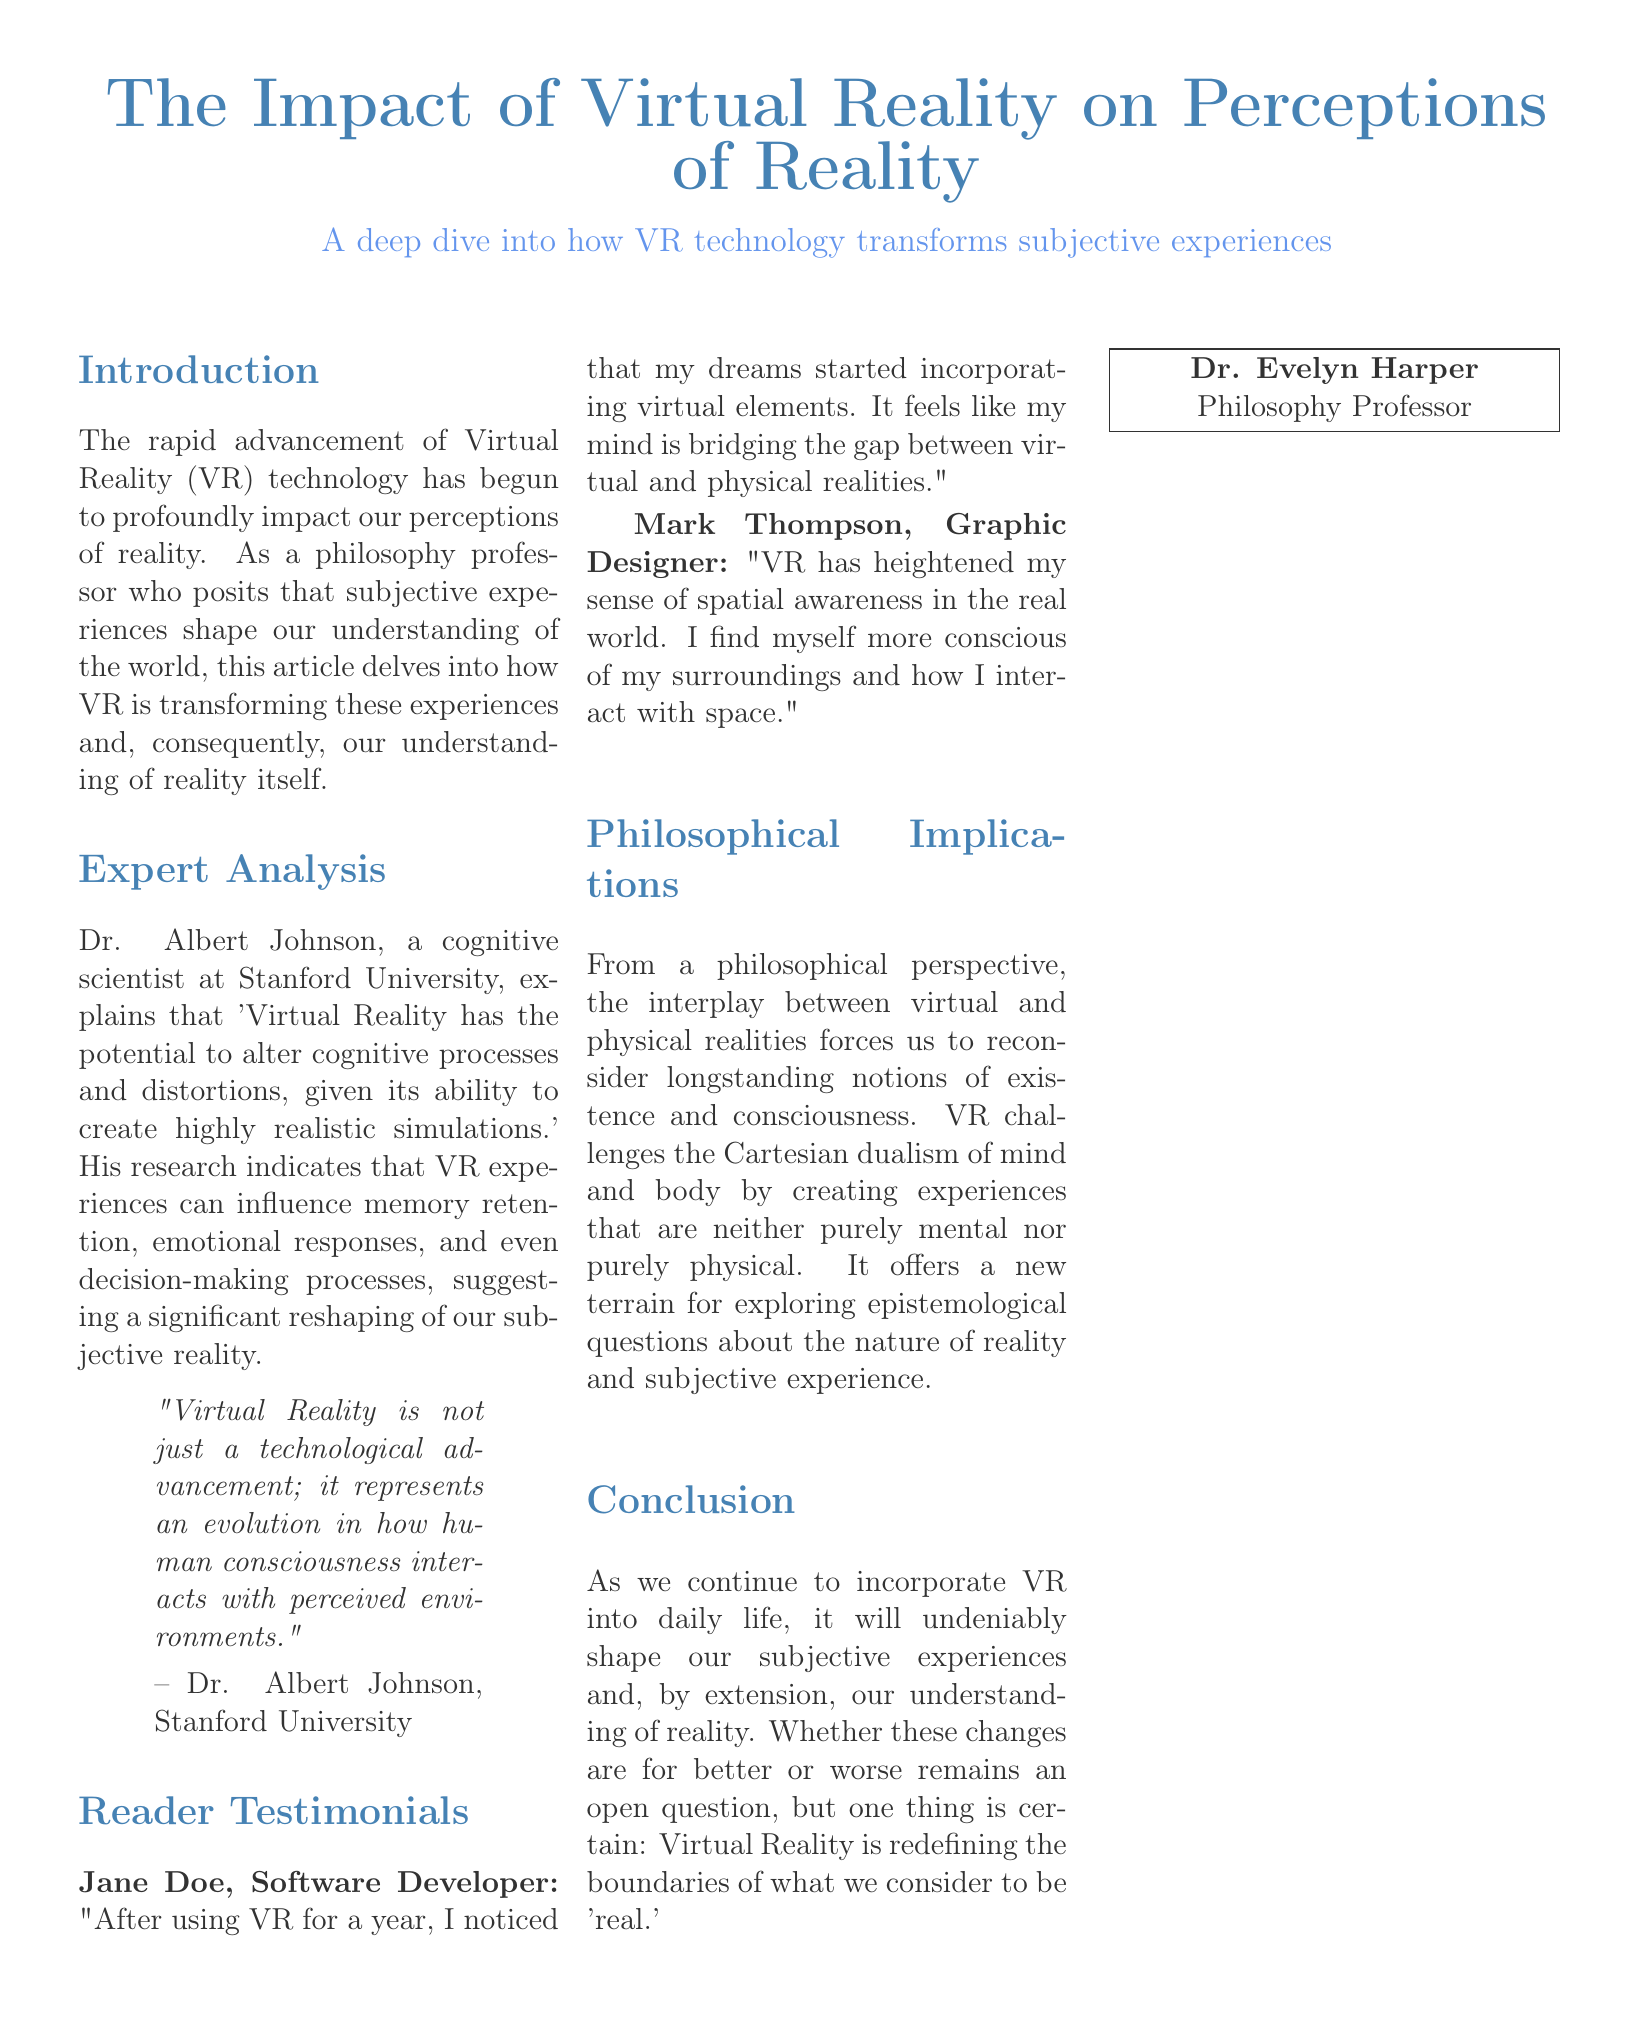What is the title of the article? The title is prominently displayed at the beginning of the document, stating the main focus on Virtual Reality's impact.
Answer: The Impact of Virtual Reality on Perceptions of Reality Who is the expert mentioned in the article? The expert's name is provided in the "Expert Analysis" section, highlighting their credentials and affiliation.
Answer: Dr. Albert Johnson What university is Dr. Albert Johnson affiliated with? The university is explicitly stated after Dr. Albert Johnson's name, indicating where he conducts his research.
Answer: Stanford University What does Jane Doe notice after using VR for a year? This information is found in the "Reader Testimonials" section, summarizing her personal experience with VR technology.
Answer: Her dreams started incorporating virtual elements What philosophical notion does VR challenge according to the document? The article discusses a philosophical concept in the "Philosophical Implications" section, where concepts related to existence are questioned.
Answer: Cartesian dualism According to the expert, what does VR represent in relation to human consciousness? This quote captures the essence of Dr. Johnson's perspective on the impact of VR on consciousness.
Answer: An evolution in how human consciousness interacts with perceived environments What effect does Mark Thompson attribute to using VR? This effect is described in his testimonial, relating to his increased awareness after using VR.
Answer: Heightened sense of spatial awareness What is the conclusion about the impact of VR on reality in the document? This sentiment is summarized at the end of the document, reflecting on the transformative implications of VR.
Answer: Redefining the boundaries of what we consider to be 'real' 